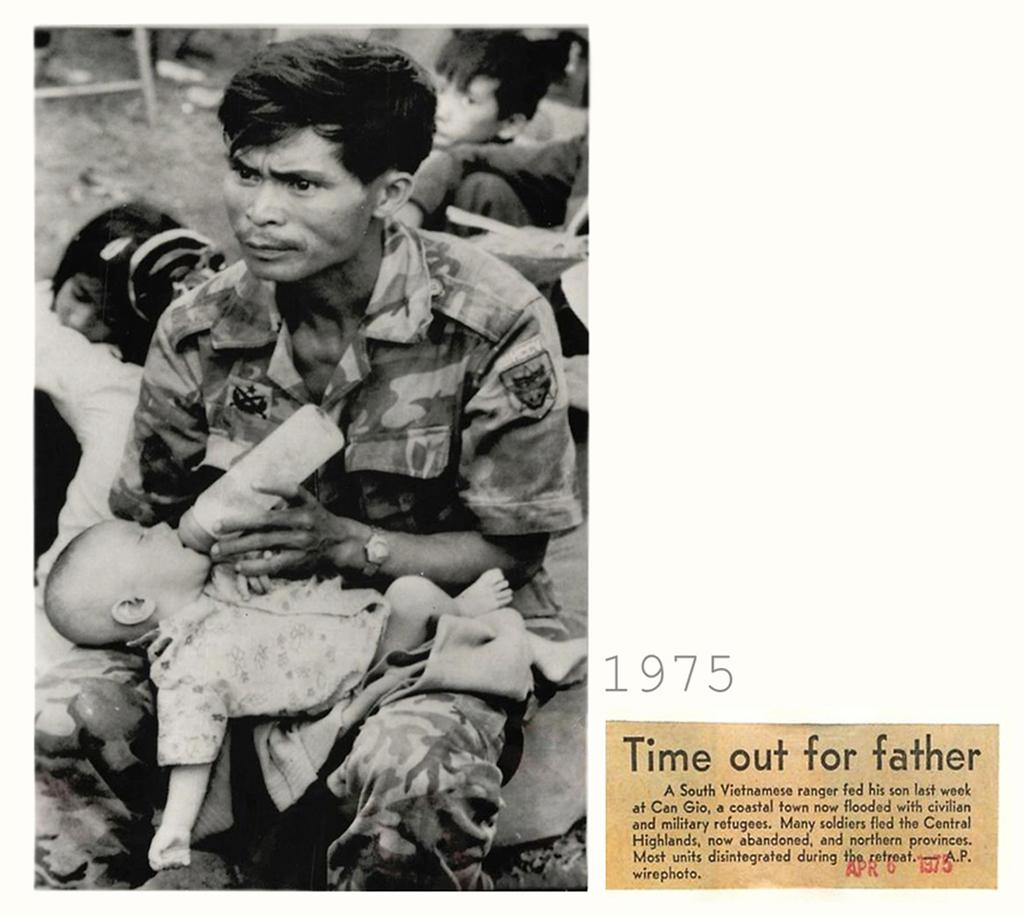What is the man in the image doing? The man is sitting and feeding a baby. Can you describe the people in the background of the image? There are people in the background of the image, but their specific actions or characteristics are not mentioned in the provided facts. What is the relationship between the man and the baby in the image? The man is feeding the baby, which suggests a caregiver or parental relationship. What type of rock is being used as a symbol of peace in the image? There is no rock or symbol of peace present in the image; it features a man feeding a baby. 